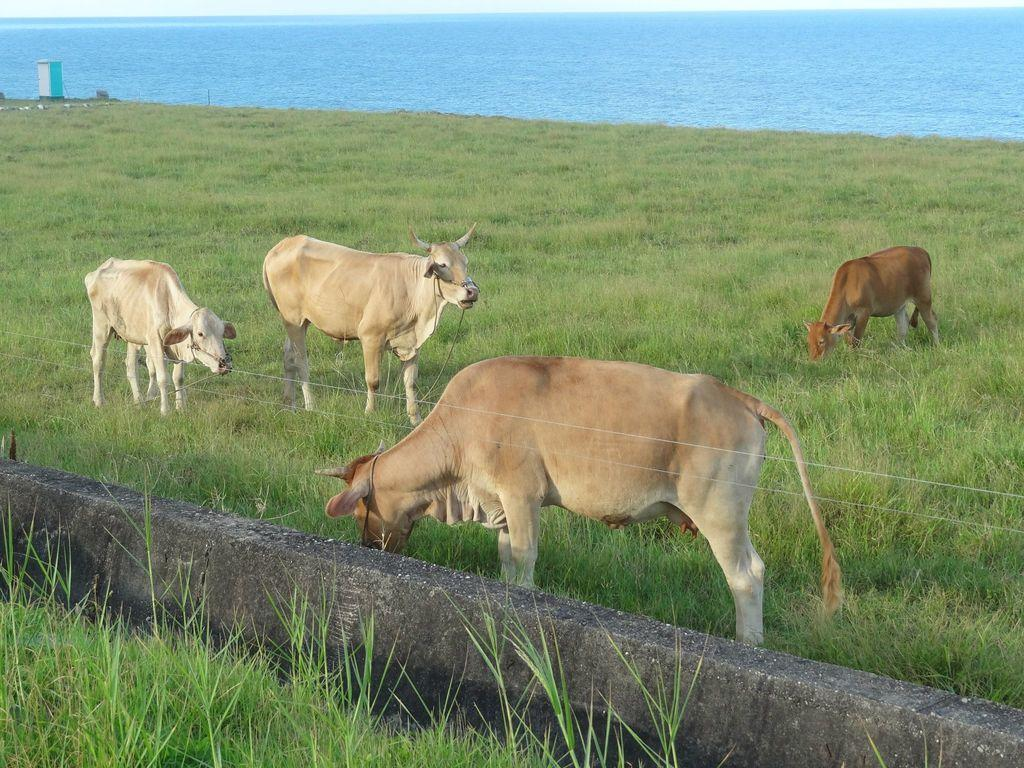How many cows are present in the image? There are four cows in the image. What type of vegetation is on the ground? The ground is full of grass. Can you describe the water visible in the image? Unfortunately, the facts provided do not give any details about the water, so we cannot describe it. What type of goose can be seen answering questions in the image? There is no goose present in the image, let alone one answering questions. 